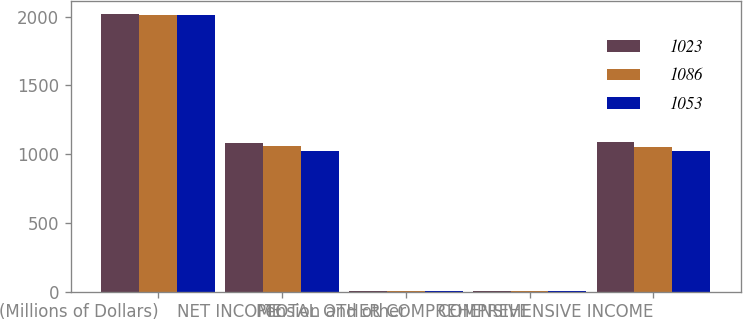Convert chart. <chart><loc_0><loc_0><loc_500><loc_500><stacked_bar_chart><ecel><fcel>(Millions of Dollars)<fcel>NET INCOME<fcel>Pension and other<fcel>TOTAL OTHER COMPREHENSIVE<fcel>COMPREHENSIVE INCOME<nl><fcel>1023<fcel>2015<fcel>1084<fcel>2<fcel>2<fcel>1086<nl><fcel>1086<fcel>2014<fcel>1058<fcel>5<fcel>5<fcel>1053<nl><fcel>1053<fcel>2013<fcel>1020<fcel>3<fcel>3<fcel>1023<nl></chart> 